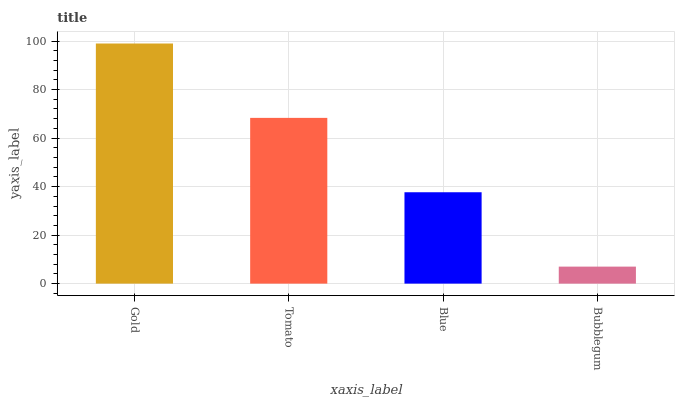Is Bubblegum the minimum?
Answer yes or no. Yes. Is Gold the maximum?
Answer yes or no. Yes. Is Tomato the minimum?
Answer yes or no. No. Is Tomato the maximum?
Answer yes or no. No. Is Gold greater than Tomato?
Answer yes or no. Yes. Is Tomato less than Gold?
Answer yes or no. Yes. Is Tomato greater than Gold?
Answer yes or no. No. Is Gold less than Tomato?
Answer yes or no. No. Is Tomato the high median?
Answer yes or no. Yes. Is Blue the low median?
Answer yes or no. Yes. Is Bubblegum the high median?
Answer yes or no. No. Is Tomato the low median?
Answer yes or no. No. 